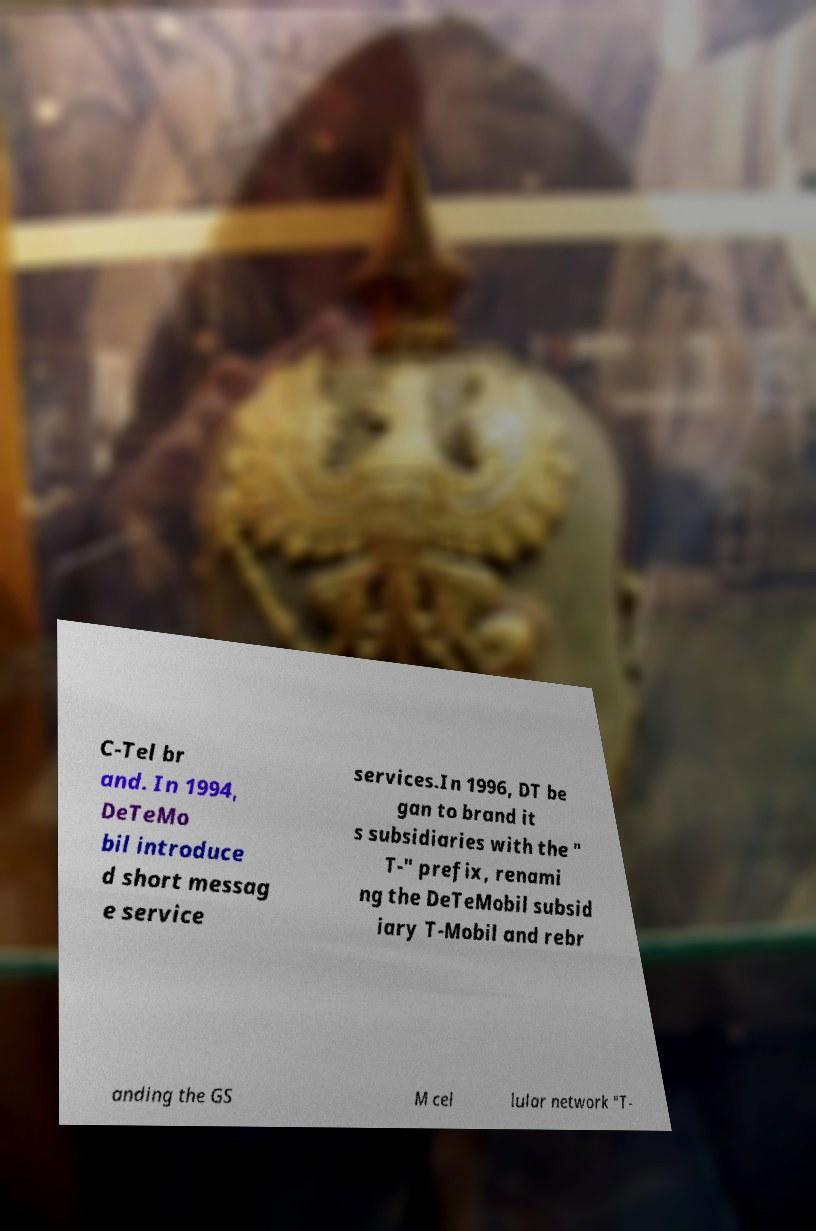Can you read and provide the text displayed in the image?This photo seems to have some interesting text. Can you extract and type it out for me? C-Tel br and. In 1994, DeTeMo bil introduce d short messag e service services.In 1996, DT be gan to brand it s subsidiaries with the " T-" prefix, renami ng the DeTeMobil subsid iary T-Mobil and rebr anding the GS M cel lular network "T- 